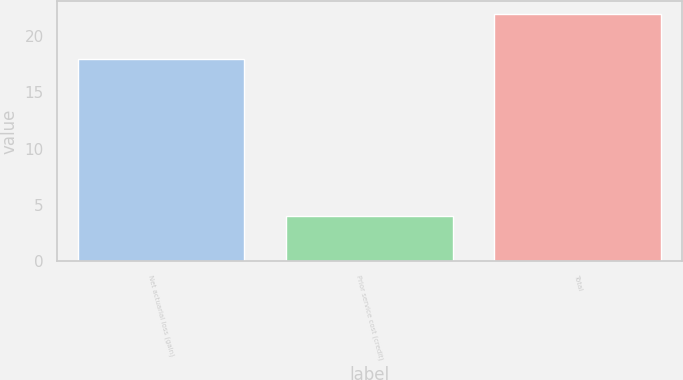Convert chart. <chart><loc_0><loc_0><loc_500><loc_500><bar_chart><fcel>Net actuarial loss (gain)<fcel>Prior service cost (credit)<fcel>Total<nl><fcel>18<fcel>4<fcel>22<nl></chart> 